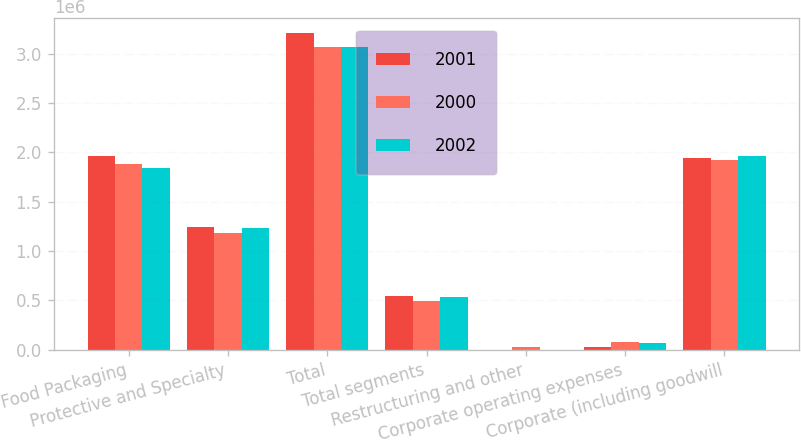Convert chart. <chart><loc_0><loc_0><loc_500><loc_500><stacked_bar_chart><ecel><fcel>Food Packaging<fcel>Protective and Specialty<fcel>Total<fcel>Total segments<fcel>Restructuring and other<fcel>Corporate operating expenses<fcel>Corporate (including goodwill<nl><fcel>2001<fcel>1.95808e+06<fcel>1.24618e+06<fcel>3.20426e+06<fcel>544660<fcel>1348<fcel>29622<fcel>1.94349e+06<nl><fcel>2000<fcel>1.88028e+06<fcel>1.1872e+06<fcel>3.06748e+06<fcel>498683<fcel>32805<fcel>78487<fcel>1.91963e+06<nl><fcel>2002<fcel>1.83729e+06<fcel>1.23042e+06<fcel>3.06771e+06<fcel>538564<fcel>1247<fcel>71348<fcel>1.96441e+06<nl></chart> 